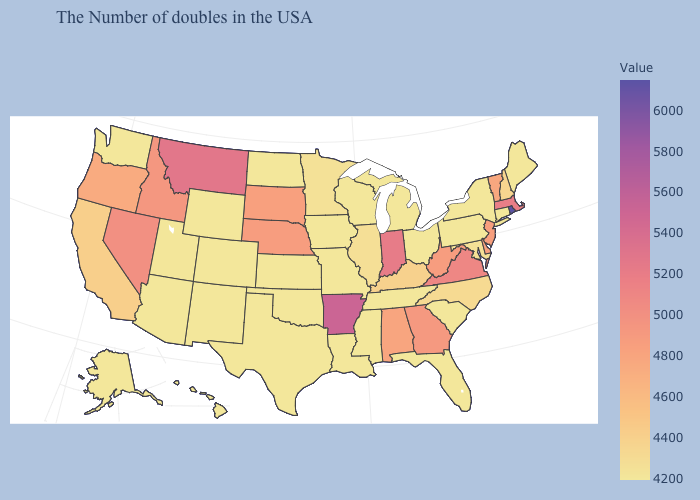Which states hav the highest value in the MidWest?
Write a very short answer. Indiana. Does the map have missing data?
Keep it brief. No. Does Rhode Island have the highest value in the USA?
Give a very brief answer. Yes. 